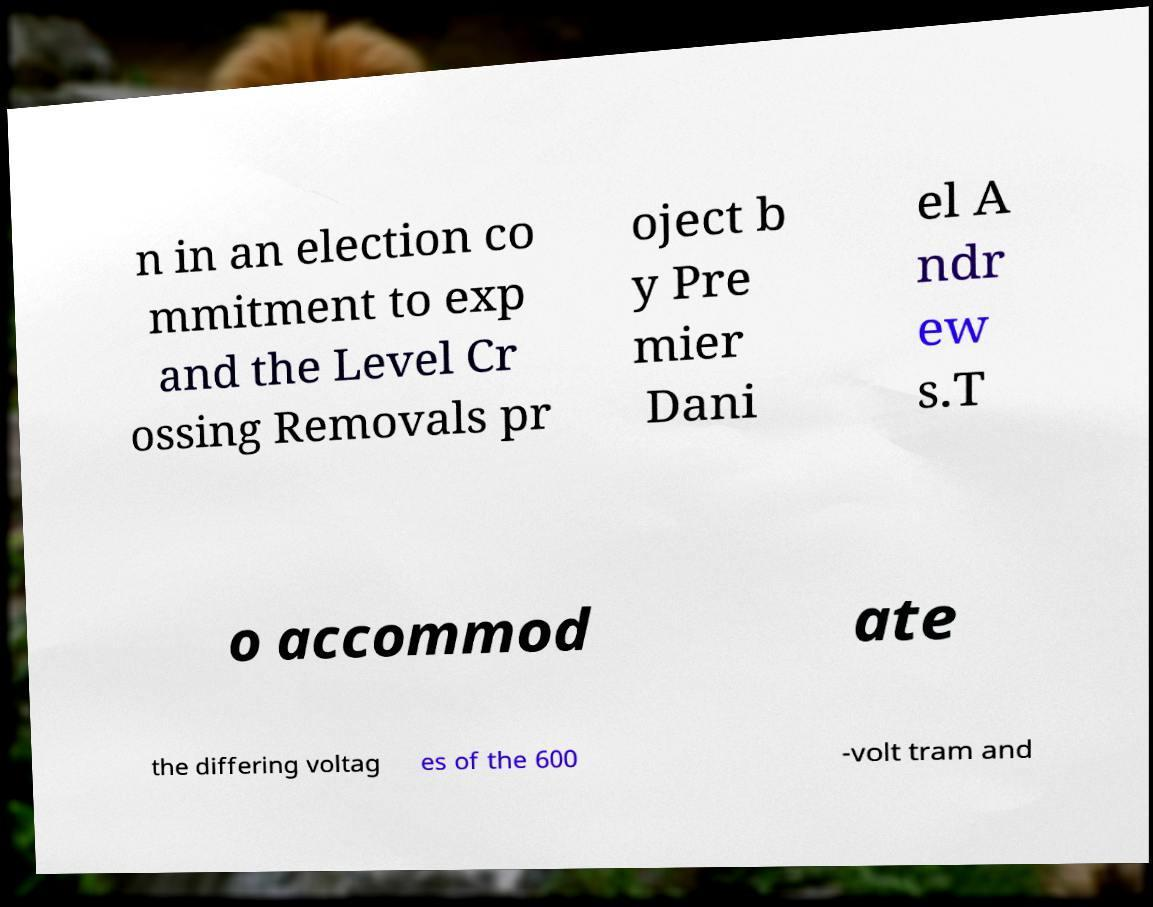Could you assist in decoding the text presented in this image and type it out clearly? n in an election co mmitment to exp and the Level Cr ossing Removals pr oject b y Pre mier Dani el A ndr ew s.T o accommod ate the differing voltag es of the 600 -volt tram and 